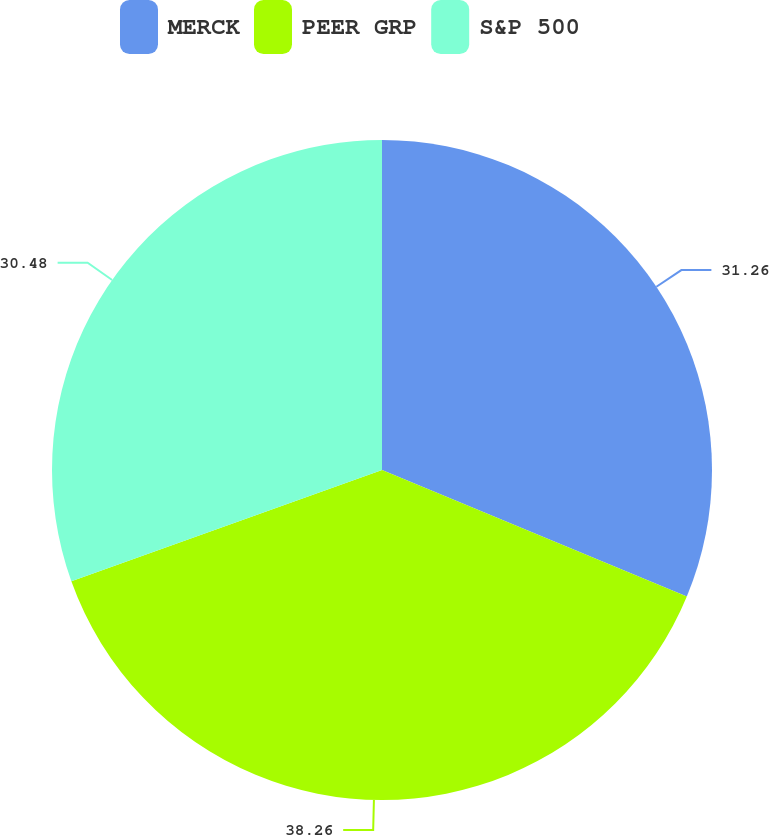<chart> <loc_0><loc_0><loc_500><loc_500><pie_chart><fcel>MERCK<fcel>PEER GRP<fcel>S&P 500<nl><fcel>31.26%<fcel>38.27%<fcel>30.48%<nl></chart> 